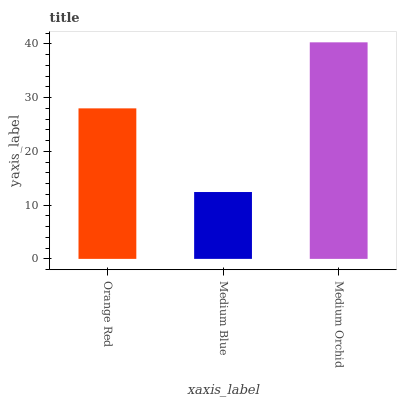Is Medium Orchid the minimum?
Answer yes or no. No. Is Medium Blue the maximum?
Answer yes or no. No. Is Medium Orchid greater than Medium Blue?
Answer yes or no. Yes. Is Medium Blue less than Medium Orchid?
Answer yes or no. Yes. Is Medium Blue greater than Medium Orchid?
Answer yes or no. No. Is Medium Orchid less than Medium Blue?
Answer yes or no. No. Is Orange Red the high median?
Answer yes or no. Yes. Is Orange Red the low median?
Answer yes or no. Yes. Is Medium Orchid the high median?
Answer yes or no. No. Is Medium Blue the low median?
Answer yes or no. No. 